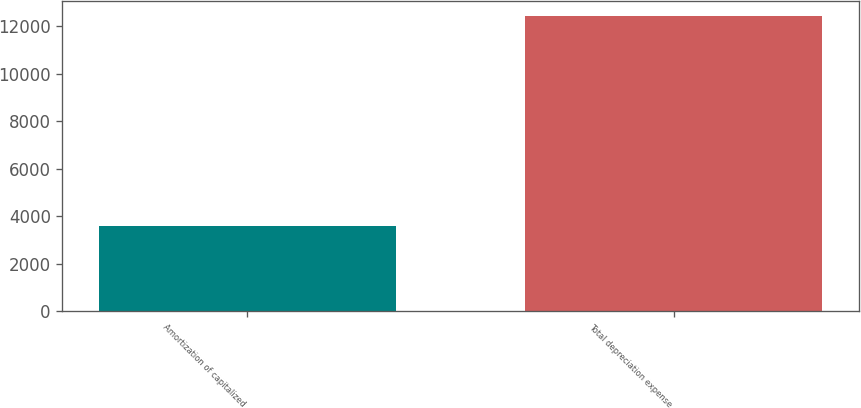<chart> <loc_0><loc_0><loc_500><loc_500><bar_chart><fcel>Amortization of capitalized<fcel>Total depreciation expense<nl><fcel>3600<fcel>12434<nl></chart> 